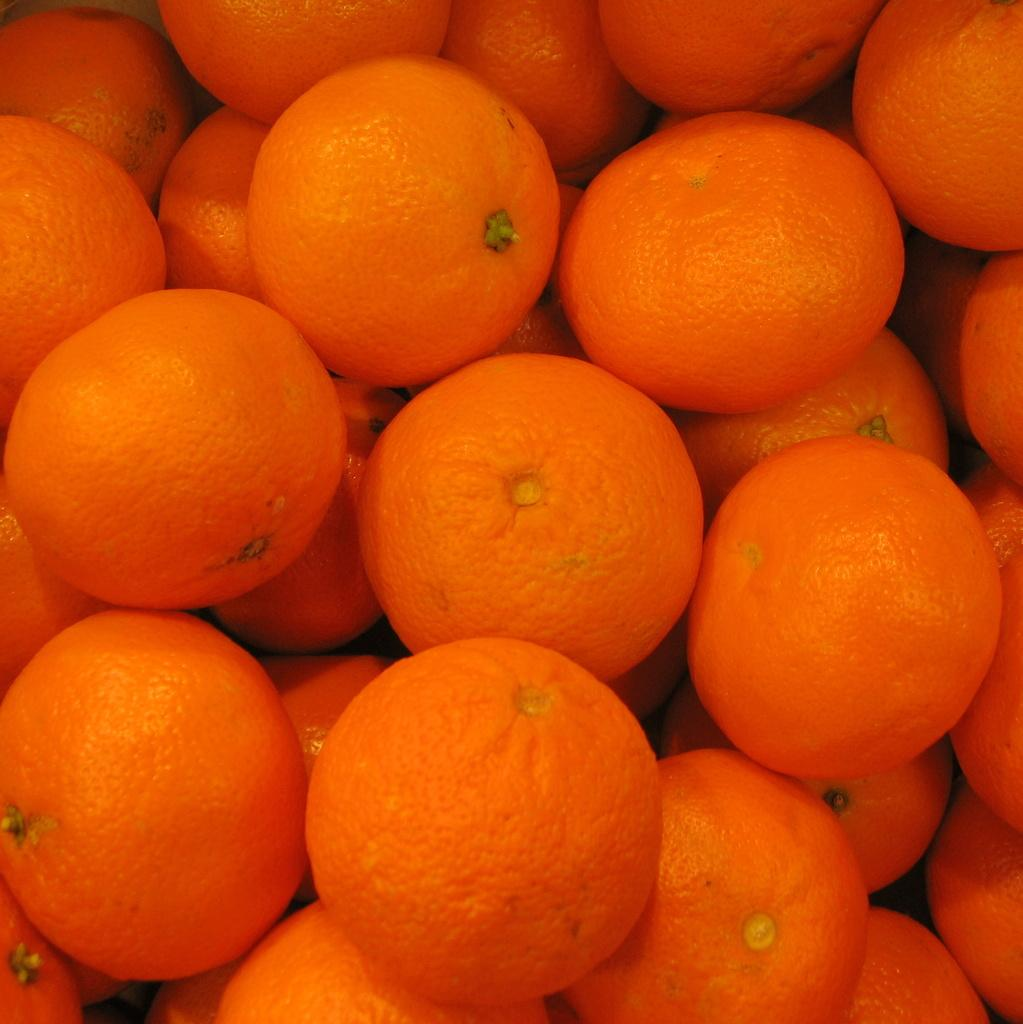What type of fruit is predominantly featured in the image? There are many oranges in the image. Can you describe the color and shape of the oranges? The oranges are round and have a bright orange color. How might the oranges be used or consumed? The oranges can be eaten fresh, juiced, or used in various recipes. What type of knee surgery is being performed on the oranges in the image? There is no knee surgery or any medical procedure being performed on the oranges in the image; it simply features a collection of oranges. 